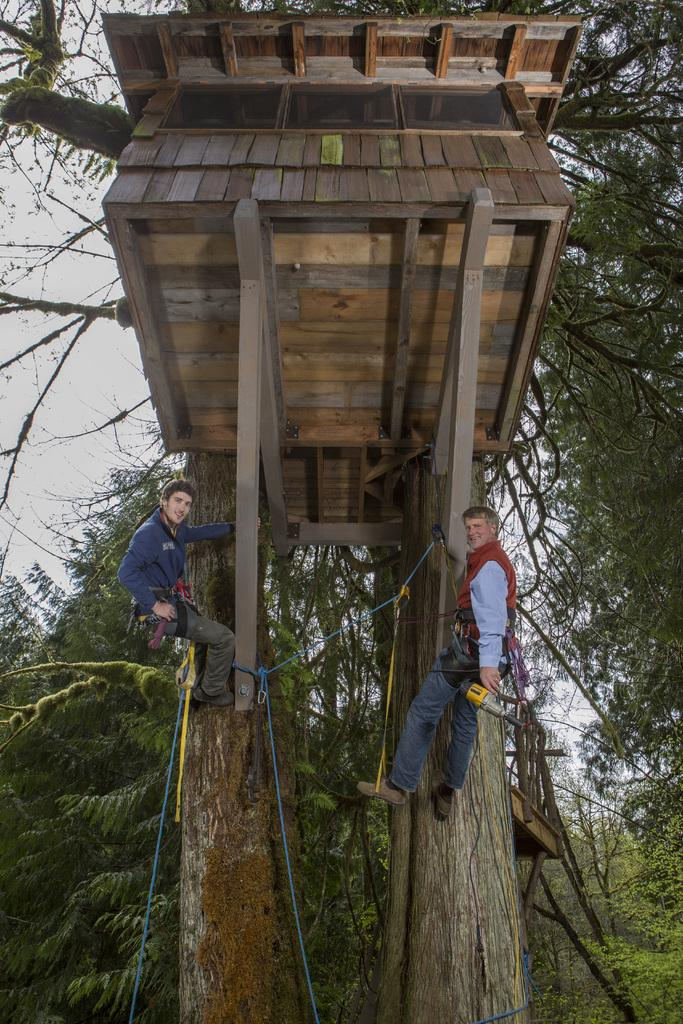What type of people can be seen in the image? There are men in the image. What is the condition of the men in the image? The men are tied with ropes. What is the man holding in the image? There is a man holding a machine in the image. Can you describe the unique structure in the image? There is a wooden house on a tree in the image. What is visible in the background of the image? The sky is visible in the image. What type of grape is being used to power the machine in the image? There is no grape present in the image, and the machine is not powered by grapes. How does the train in the image affect the decision-making process of the men? There is no train present in the image, so it cannot affect the decision-making process of the men. 